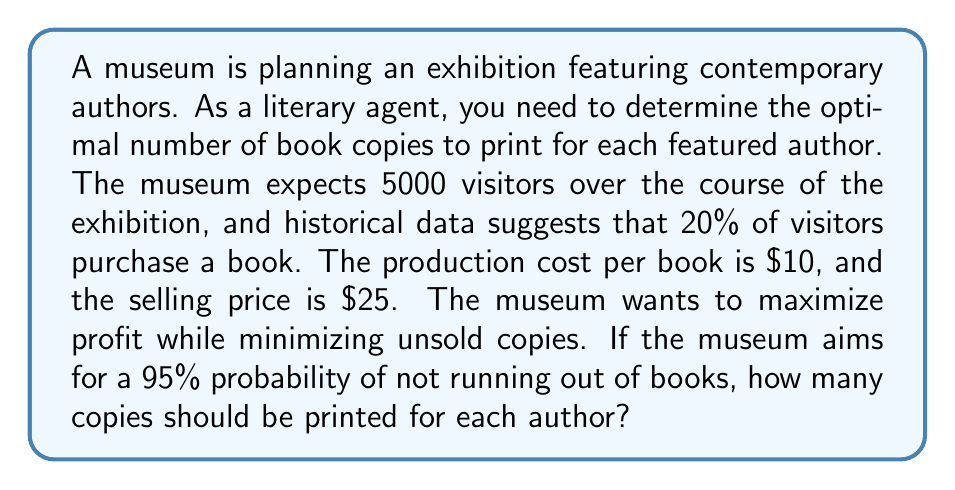Give your solution to this math problem. To solve this problem, we'll use concepts from probability theory and the normal distribution.

1. Calculate the expected number of books sold:
   $$ E(\text{books sold}) = 5000 \times 0.20 = 1000 $$

2. Assume the number of books sold follows a normal distribution. We need to find the standard deviation. In the absence of specific data, we can estimate it as the square root of the expected value:
   $$ \sigma = \sqrt{1000} \approx 31.62 $$

3. For a 95% probability of not running out of books, we need to find the z-score corresponding to the 95th percentile of the standard normal distribution. This z-score is approximately 1.645.

4. Calculate the number of books needed to meet the 95% threshold:
   $$ \text{Number of books} = E(\text{books sold}) + z \times \sigma $$
   $$ = 1000 + 1.645 \times 31.62 \approx 1052 $$

5. Round up to the nearest whole number: 1052

6. Verify the profit:
   - Revenue: $1052 \times $25 = $26,300
   - Cost: $1052 \times $10 = $10,520
   - Profit: $26,300 - $10,520 = $15,780

Therefore, the optimal number of book copies to print for each featured author is 1052.
Answer: 1052 copies 